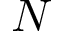<formula> <loc_0><loc_0><loc_500><loc_500>N</formula> 